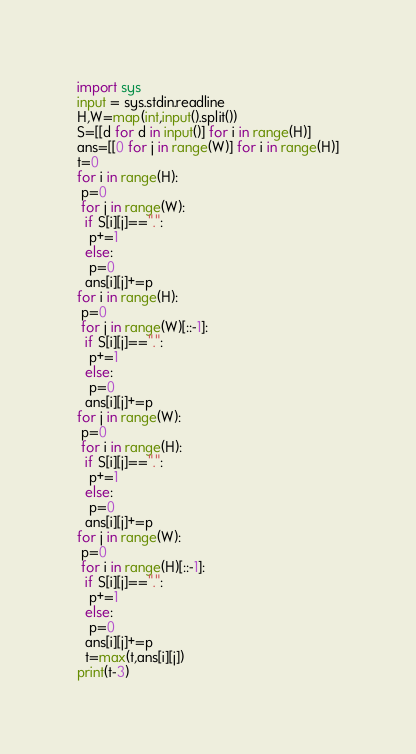Convert code to text. <code><loc_0><loc_0><loc_500><loc_500><_Python_>import sys
input = sys.stdin.readline
H,W=map(int,input().split())
S=[[d for d in input()] for i in range(H)]
ans=[[0 for j in range(W)] for i in range(H)]
t=0
for i in range(H):
 p=0
 for j in range(W):
  if S[i][j]==".":
   p+=1
  else:
   p=0
  ans[i][j]+=p
for i in range(H):
 p=0
 for j in range(W)[::-1]:
  if S[i][j]==".":
   p+=1
  else:
   p=0
  ans[i][j]+=p
for j in range(W):
 p=0
 for i in range(H):
  if S[i][j]==".":
   p+=1
  else:
   p=0
  ans[i][j]+=p
for j in range(W):
 p=0
 for i in range(H)[::-1]:
  if S[i][j]==".":
   p+=1
  else:
   p=0
  ans[i][j]+=p
  t=max(t,ans[i][j])
print(t-3)</code> 